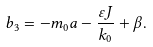Convert formula to latex. <formula><loc_0><loc_0><loc_500><loc_500>b _ { 3 } = - m _ { 0 } a - \frac { \varepsilon J } { k _ { 0 } } + \beta .</formula> 